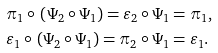Convert formula to latex. <formula><loc_0><loc_0><loc_500><loc_500>& \pi _ { 1 } \circ \, \left ( \Psi _ { 2 } \circ \Psi _ { 1 } \right ) = \varepsilon _ { 2 } \circ \Psi _ { 1 } = \pi _ { 1 } , \\ & \varepsilon _ { 1 } \circ \, \left ( \Psi _ { 2 } \circ \Psi _ { 1 } \right ) = \pi _ { 2 } \circ \Psi _ { 1 } = \varepsilon _ { 1 } .</formula> 